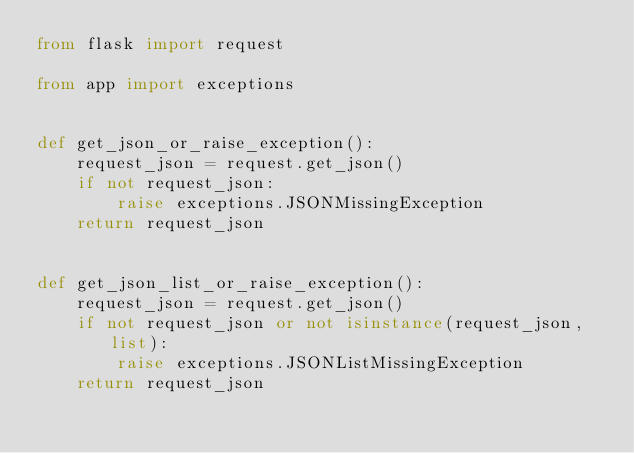<code> <loc_0><loc_0><loc_500><loc_500><_Python_>from flask import request

from app import exceptions


def get_json_or_raise_exception():
    request_json = request.get_json()
    if not request_json:
        raise exceptions.JSONMissingException
    return request_json


def get_json_list_or_raise_exception():
    request_json = request.get_json()
    if not request_json or not isinstance(request_json, list):
        raise exceptions.JSONListMissingException
    return request_json
</code> 